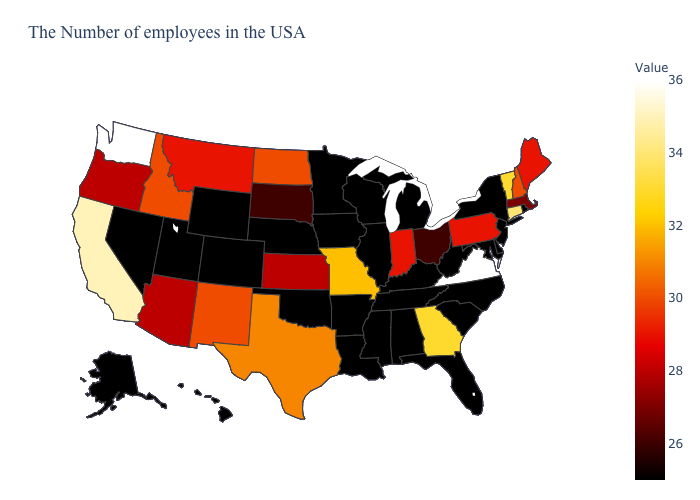Does Washington have the highest value in the USA?
Concise answer only. Yes. Does Virginia have the highest value in the South?
Answer briefly. Yes. Which states have the lowest value in the Northeast?
Be succinct. Rhode Island, New York, New Jersey. Among the states that border North Dakota , which have the lowest value?
Concise answer only. Minnesota. Does Washington have a higher value than Vermont?
Keep it brief. Yes. Does Michigan have the highest value in the MidWest?
Answer briefly. No. Among the states that border Montana , which have the lowest value?
Quick response, please. Wyoming. 